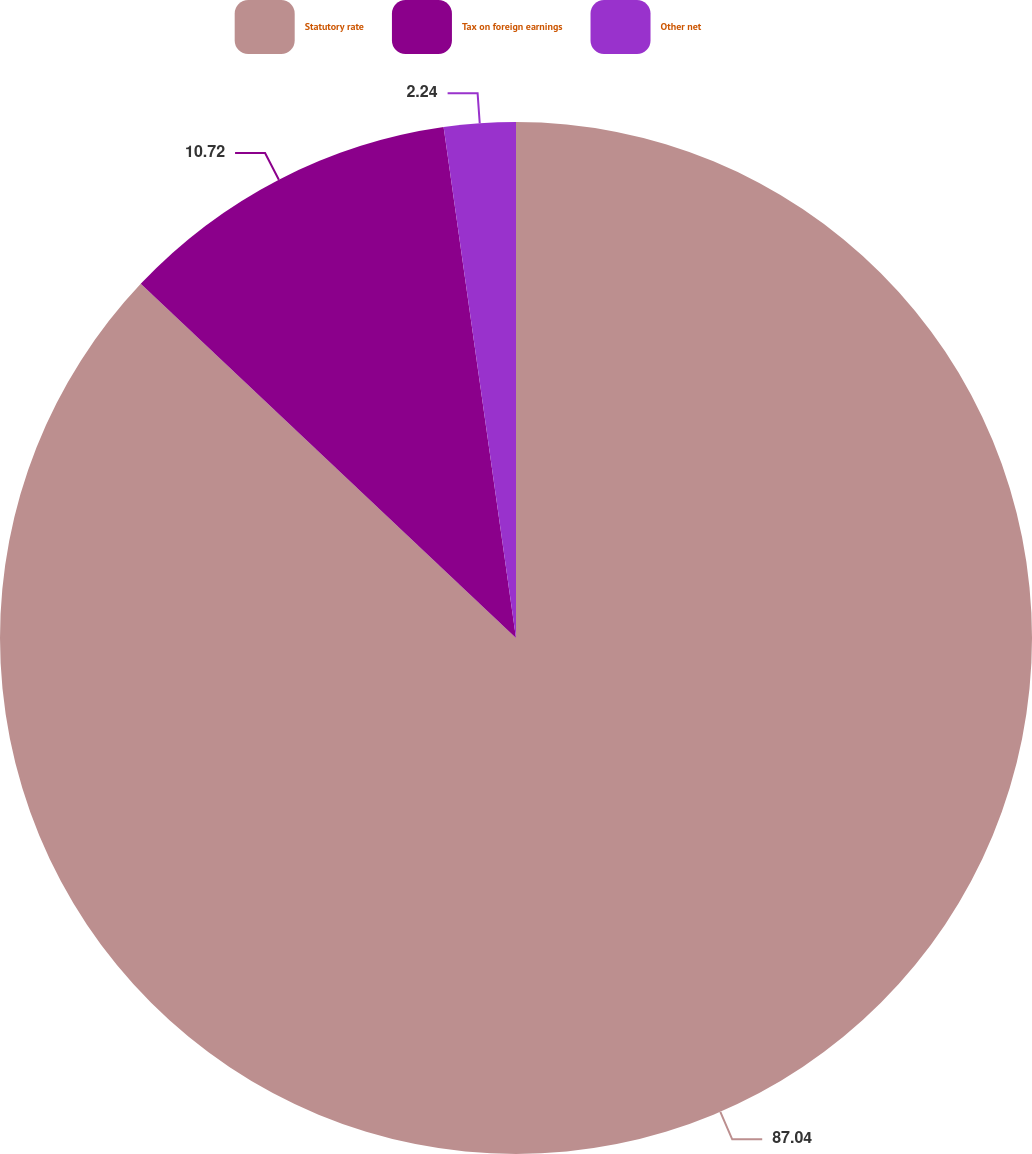Convert chart. <chart><loc_0><loc_0><loc_500><loc_500><pie_chart><fcel>Statutory rate<fcel>Tax on foreign earnings<fcel>Other net<nl><fcel>87.04%<fcel>10.72%<fcel>2.24%<nl></chart> 